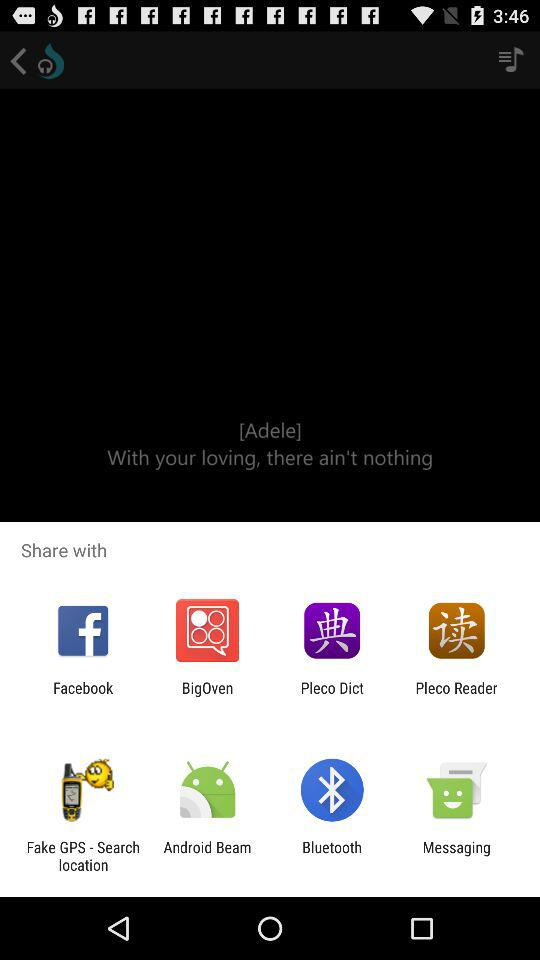Which application can I use for sharing the content? You can use "Facebook", "BigOven", "Pleco Dict", "Pleco Reader", "Fake GPS - Search location", "Android Beam", "Bluetooth" and "Messaging" for sharing the content. 